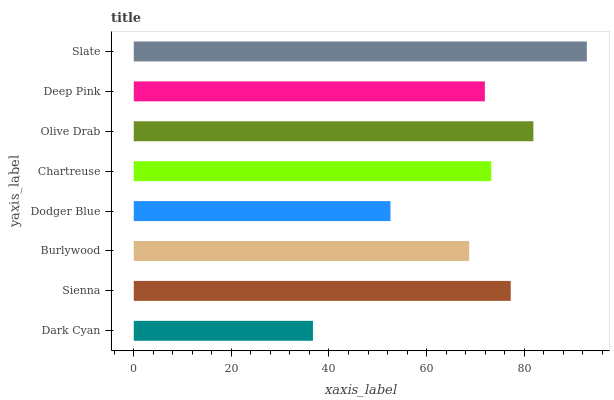Is Dark Cyan the minimum?
Answer yes or no. Yes. Is Slate the maximum?
Answer yes or no. Yes. Is Sienna the minimum?
Answer yes or no. No. Is Sienna the maximum?
Answer yes or no. No. Is Sienna greater than Dark Cyan?
Answer yes or no. Yes. Is Dark Cyan less than Sienna?
Answer yes or no. Yes. Is Dark Cyan greater than Sienna?
Answer yes or no. No. Is Sienna less than Dark Cyan?
Answer yes or no. No. Is Chartreuse the high median?
Answer yes or no. Yes. Is Deep Pink the low median?
Answer yes or no. Yes. Is Deep Pink the high median?
Answer yes or no. No. Is Chartreuse the low median?
Answer yes or no. No. 